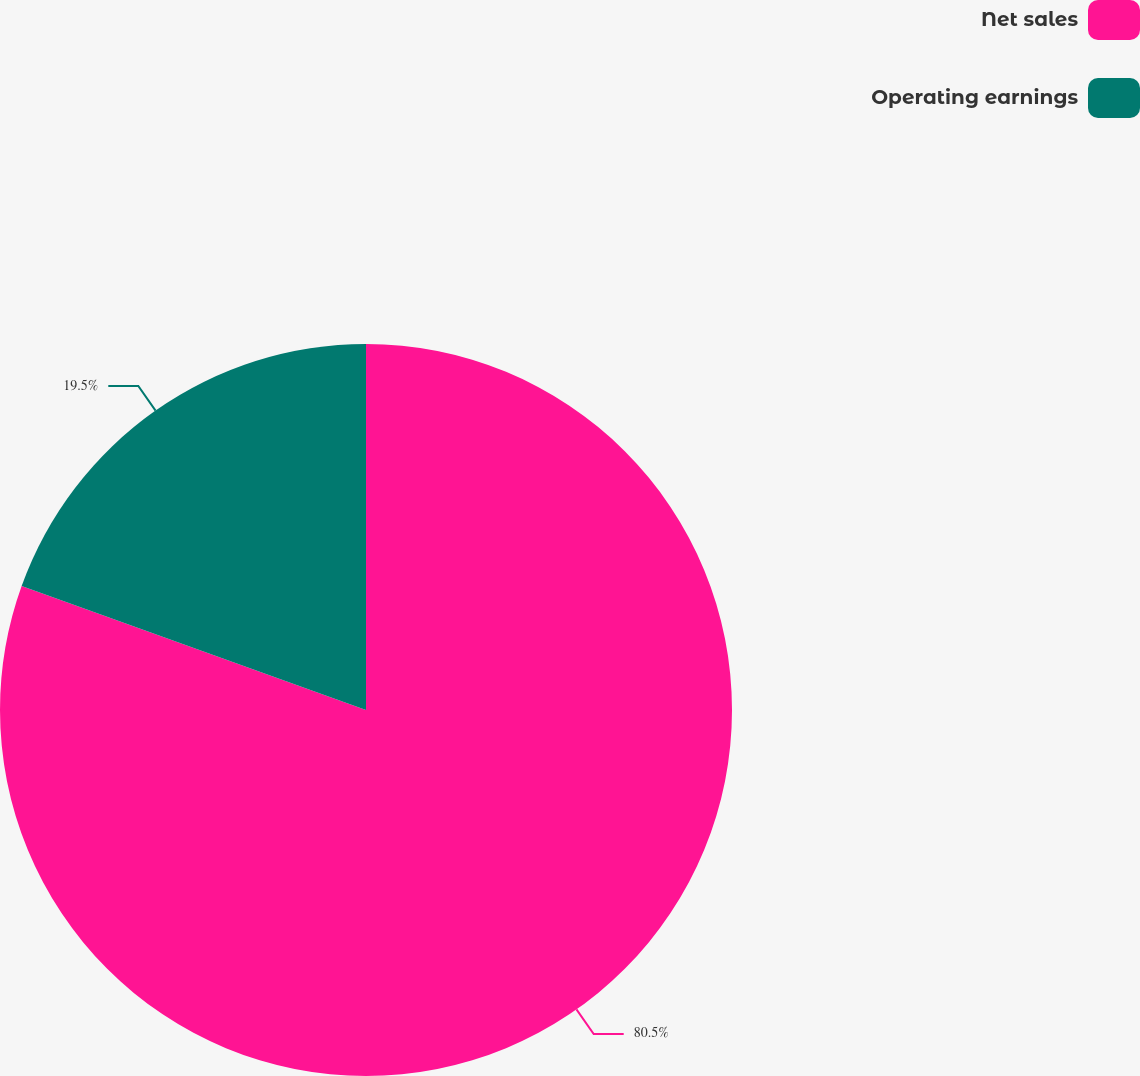Convert chart to OTSL. <chart><loc_0><loc_0><loc_500><loc_500><pie_chart><fcel>Net sales<fcel>Operating earnings<nl><fcel>80.5%<fcel>19.5%<nl></chart> 